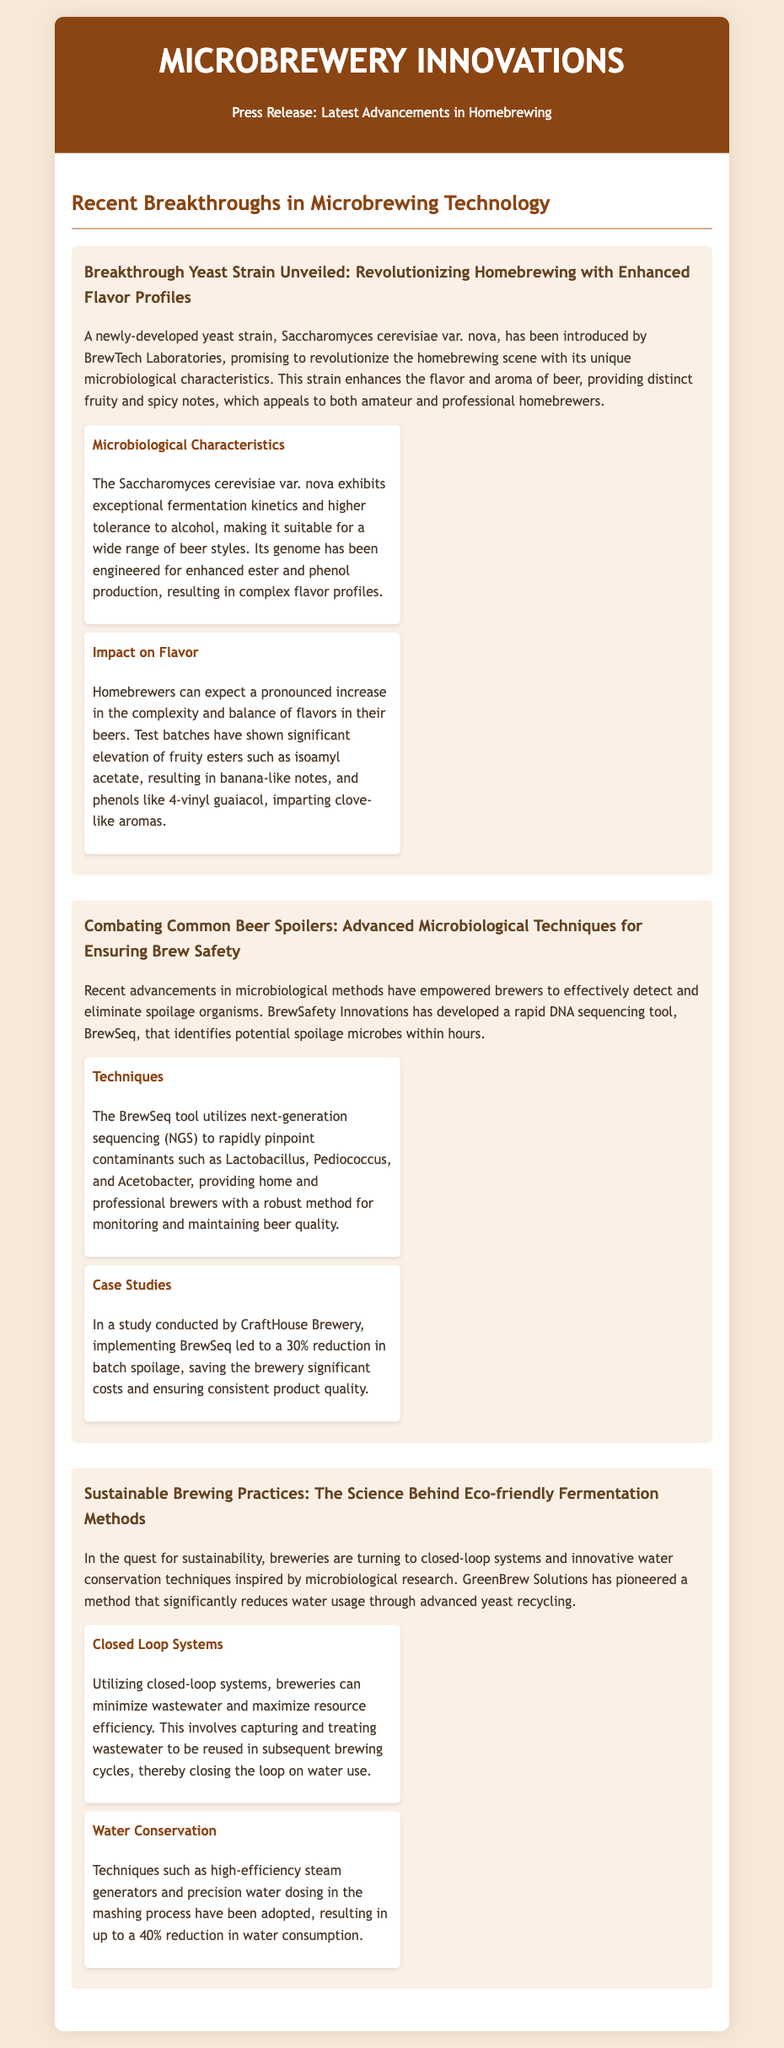What is the name of the new yeast strain? The new yeast strain introduced is called Saccharomyces cerevisiae var. nova.
Answer: Saccharomyces cerevisiae var. nova What percentage reduction in batch spoilage was achieved? The implementation of BrewSeq led to a 30% reduction in batch spoilage in the study conducted by CraftHouse Brewery.
Answer: 30% What is the primary goal of sustainable brewing practices mentioned? Sustainable brewing practices aim to reduce the environmental footprint of brewing through techniques like closed-loop systems and water conservation.
Answer: Reduce environmental footprint What company developed the rapid DNA sequencing tool? BrewSafety Innovations is the company that developed the BrewSeq tool for detecting spoilage organisms.
Answer: BrewSafety Innovations What is the main benefit of the new yeast strain for homebrewers? The main benefit of the new yeast strain is its ability to enhance the flavor and aroma of beer, providing distinct fruity and spicy notes.
Answer: Enhanced flavor and aroma What microorganism's presence does BrewSeq help identify? BrewSeq helps identify spoilage microbes such as Lactobacillus, Pediococcus, and Acetobacter.
Answer: Lactobacillus, Pediococcus, Acetobacter What is one technique mentioned for reducing water usage in brewing? High-efficiency steam generators are cited as a technique for reducing water usage in brewing processes.
Answer: High-efficiency steam generators What is a key feature of the Saccharomyces cerevisiae var. nova strain? This strain exhibits exceptional fermentation kinetics and higher tolerance to alcohol.
Answer: Exceptional fermentation kinetics What type of systems are breweries using to minimize wastewater? Breweries are using closed-loop systems to minimize wastewater during brewing.
Answer: Closed-loop systems 